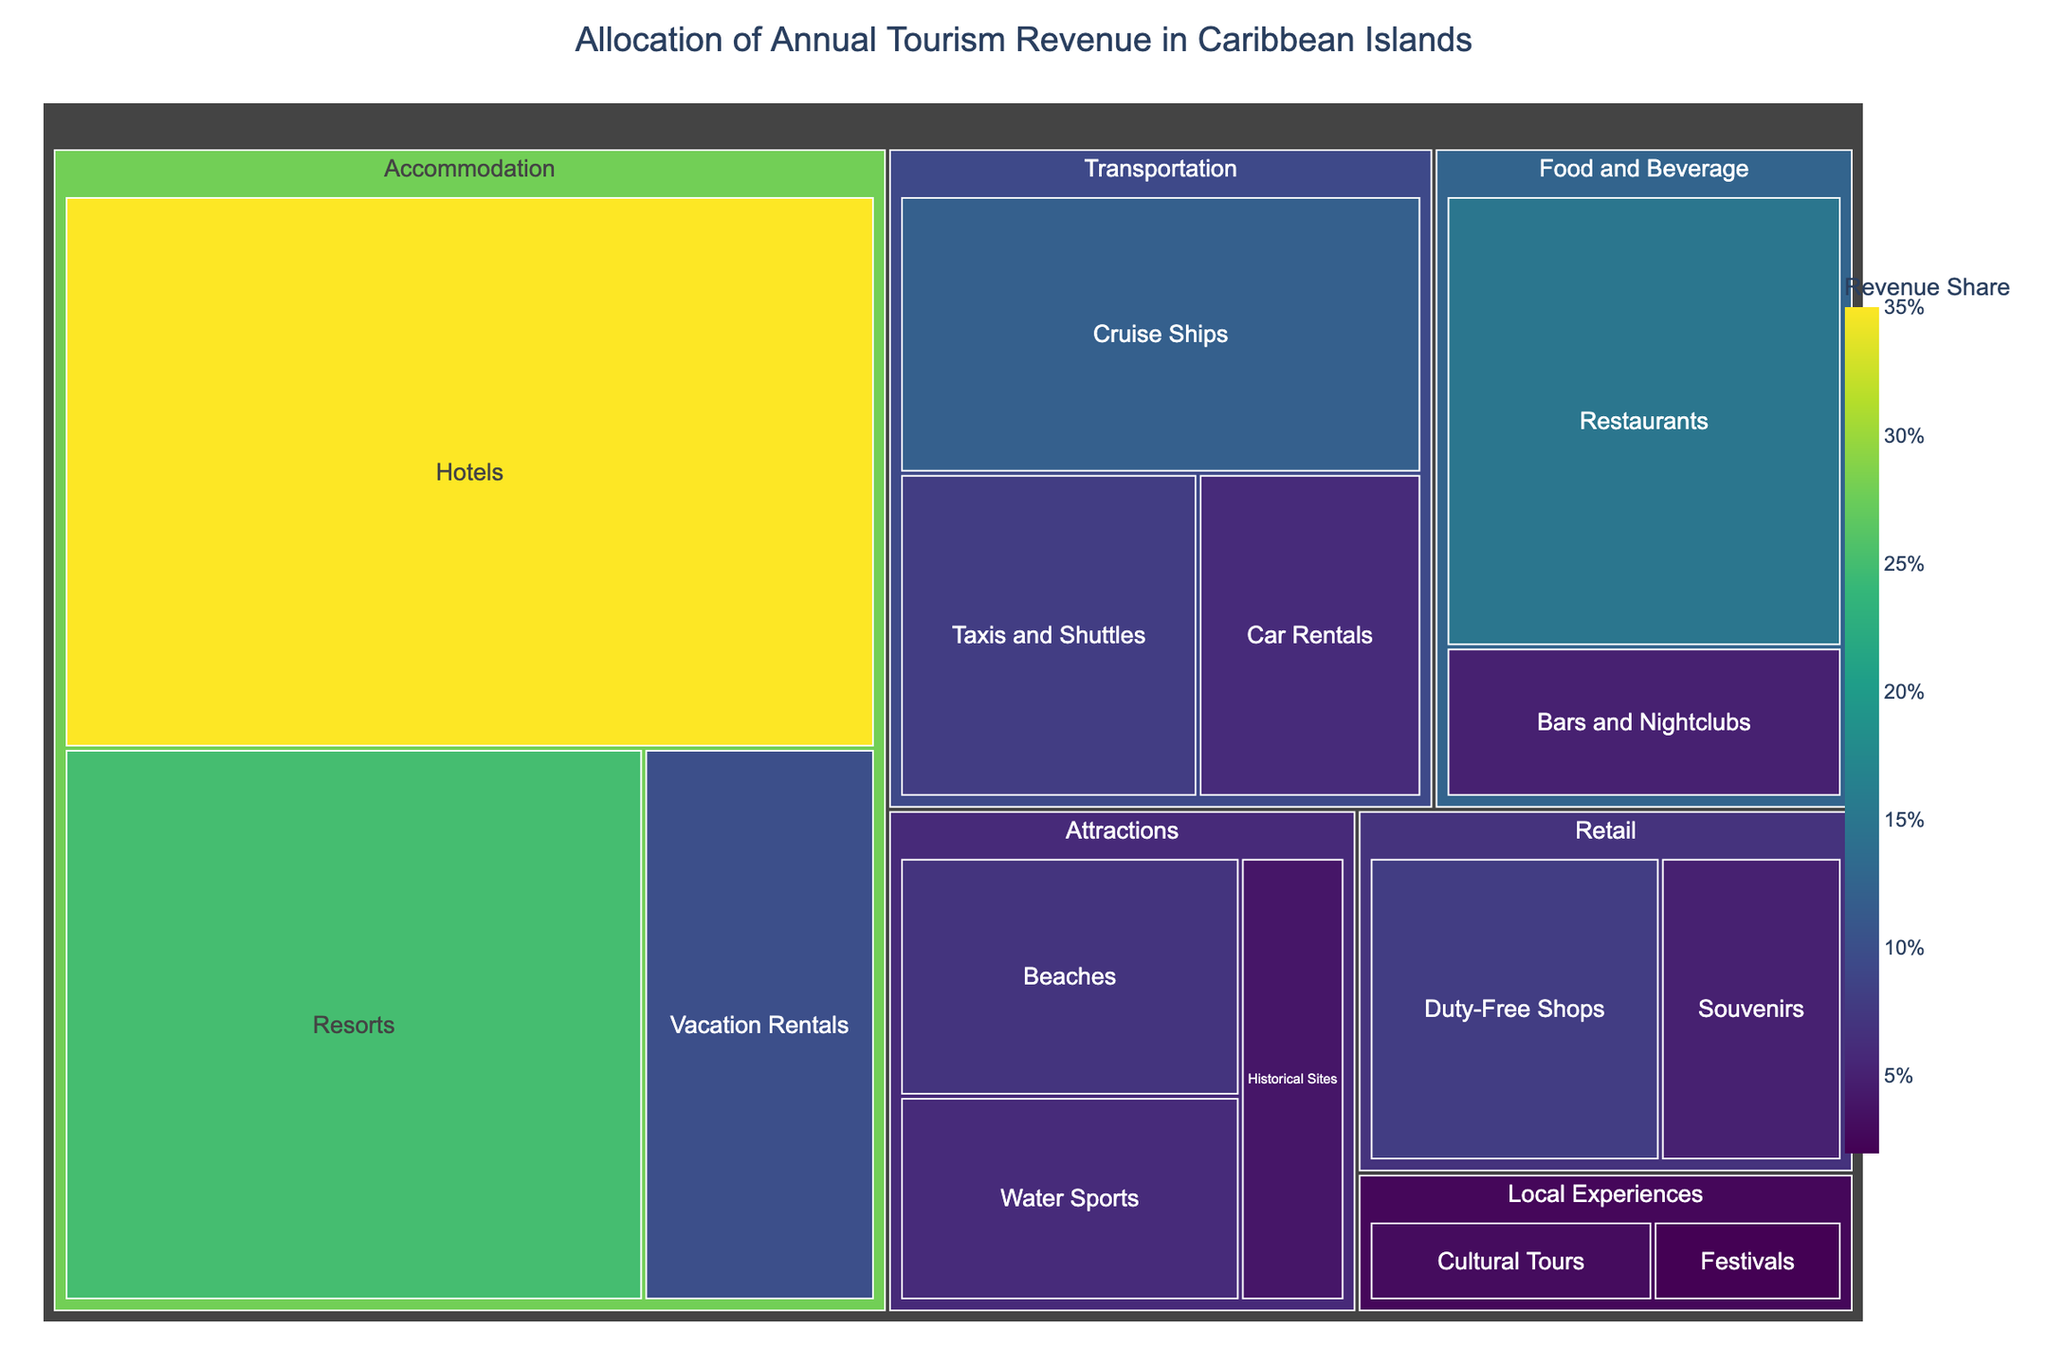What is the primary sector contributing to the annual tourism revenue? By analyzing the largest proportion in the treemap, it is evident that "Accommodation" takes up the most significant space, indicating it contributes the most to the tourism revenue.
Answer: Accommodation Which subsector under the Food and Beverage sector contributes more to the revenue? Within the Food and Beverage sector, we compare the size of the sections for "Restaurants" and "Bars and Nightclubs." "Restaurants" is larger, so it contributes more to the revenue.
Answer: Restaurants What is the total revenue share from the Local Experiences sector? In the treemap, the sizes corresponding to "Cultural Tours" and "Festivals" under Local Experiences need to be summed up. 3% for Cultural Tours and 2% for Festivals, so the total is 3 + 2 = 5%.
Answer: 5% Between Car Rentals and Taxis and Shuttles, which transportation subsector contributes less to the revenue? Comparing the sizes of the subsections, "Car Rentals" is smaller than "Taxis and Shuttles," so Car Rentals contributes less to the revenue.
Answer: Car Rentals How much revenue do the subsectors within the Retail sector collectively contribute? Summing up the values of the subsectors "Souvenirs" and "Duty-Free Shops" under Retail: 5% for Souvenirs and 8% for Duty-Free Shops, the total is 5 + 8 = 13%.
Answer: 13% What is the revenue share difference between Hotels and Resorts? The values from the treemap show Hotels at 35% and Resorts at 25%. The difference is found by subtracting: 35 - 25 = 10%.
Answer: 10% Which sector contributes more to the tourism revenue: Transportation or Attractions? The total values for Transportation (8% Taxis and Shuttles, 6% Car Rentals, 12% Cruise Ships) sum up to 26%. Similarly, the Attractions sector (7% Beaches, 4% Historical Sites, 6% Water Sports) equals 17%. Thus, Transportation contributes more.
Answer: Transportation What is the smallest contributing subsector in the treemap? From visual inspection of the treemap, "Festivals" under Local Experiences represents the smallest section, indicating it is the smallest contributor.
Answer: Festivals What's the combined revenue share of Beaches and Water Sports? Adding the values of these subsectors within the Attractions sector: 7% for Beaches and 6% for Water Sports totals to 7 + 6 = 13%.
Answer: 13% Is the revenue share from Duty-Free Shops greater than that from Taxis and Shuttles? By comparing their values in the treemap, Duty-Free Shops are at 8% and Taxis and Shuttles are at 8%. Thus, they are equal.
Answer: Equal 